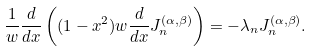Convert formula to latex. <formula><loc_0><loc_0><loc_500><loc_500>\frac { 1 } { w } \frac { d } { d x } \left ( ( 1 - x ^ { 2 } ) w \frac { d } { d x } J _ { n } ^ { ( \alpha , \beta ) } \right ) = - \lambda _ { n } J _ { n } ^ { ( \alpha , \beta ) } .</formula> 